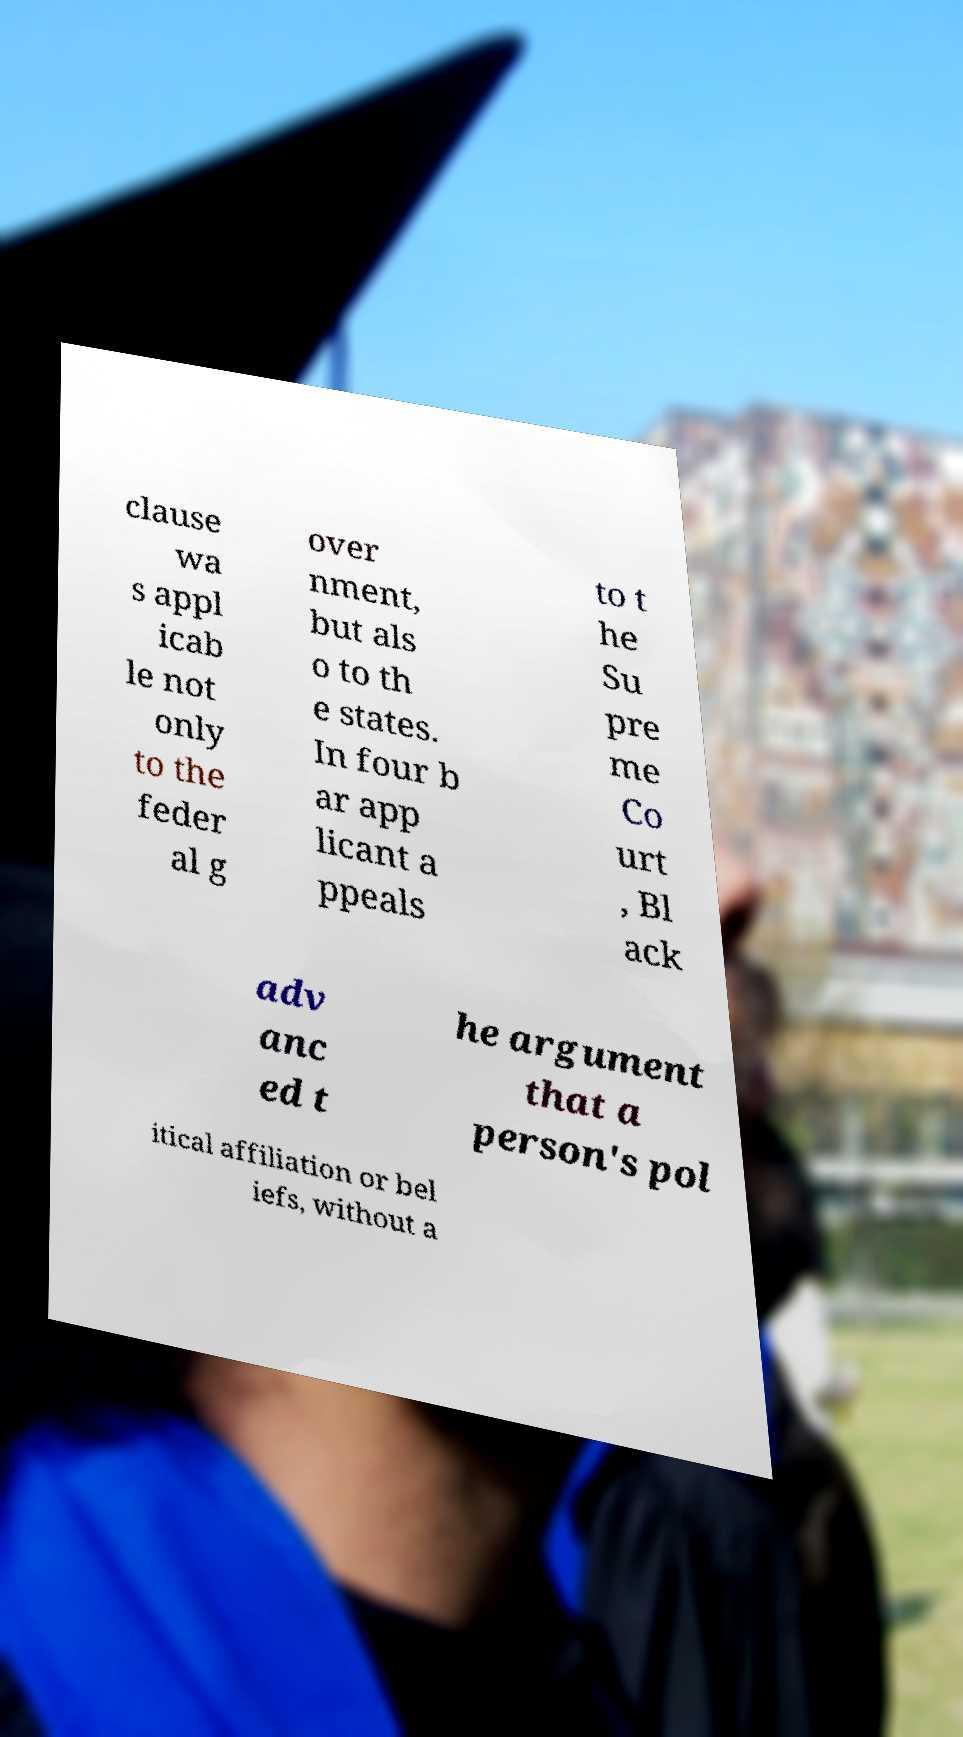Could you assist in decoding the text presented in this image and type it out clearly? clause wa s appl icab le not only to the feder al g over nment, but als o to th e states. In four b ar app licant a ppeals to t he Su pre me Co urt , Bl ack adv anc ed t he argument that a person's pol itical affiliation or bel iefs, without a 